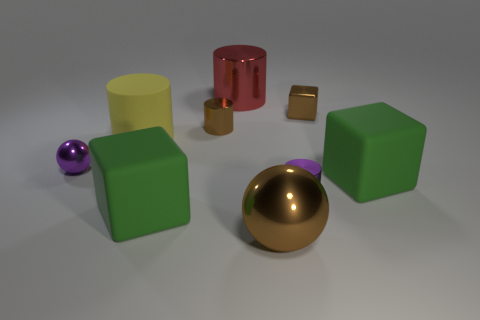Are there any other things that have the same color as the big metal cylinder?
Your response must be concise. No. There is a large brown object that is made of the same material as the small ball; what shape is it?
Offer a terse response. Sphere. Does the tiny sphere have the same color as the small metallic cube?
Offer a terse response. No. Are the big green cube that is on the left side of the red metallic cylinder and the small purple thing that is on the right side of the tiny brown cylinder made of the same material?
Keep it short and to the point. No. How many things are yellow cylinders or big green rubber objects on the right side of the red metal cylinder?
Keep it short and to the point. 2. Is there anything else that is made of the same material as the brown cylinder?
Keep it short and to the point. Yes. There is a large object that is the same color as the tiny metallic block; what is its shape?
Provide a short and direct response. Sphere. What material is the red object?
Ensure brevity in your answer.  Metal. Is the material of the small brown cylinder the same as the purple ball?
Make the answer very short. Yes. What number of shiny objects are either small red cylinders or big objects?
Your answer should be compact. 2. 